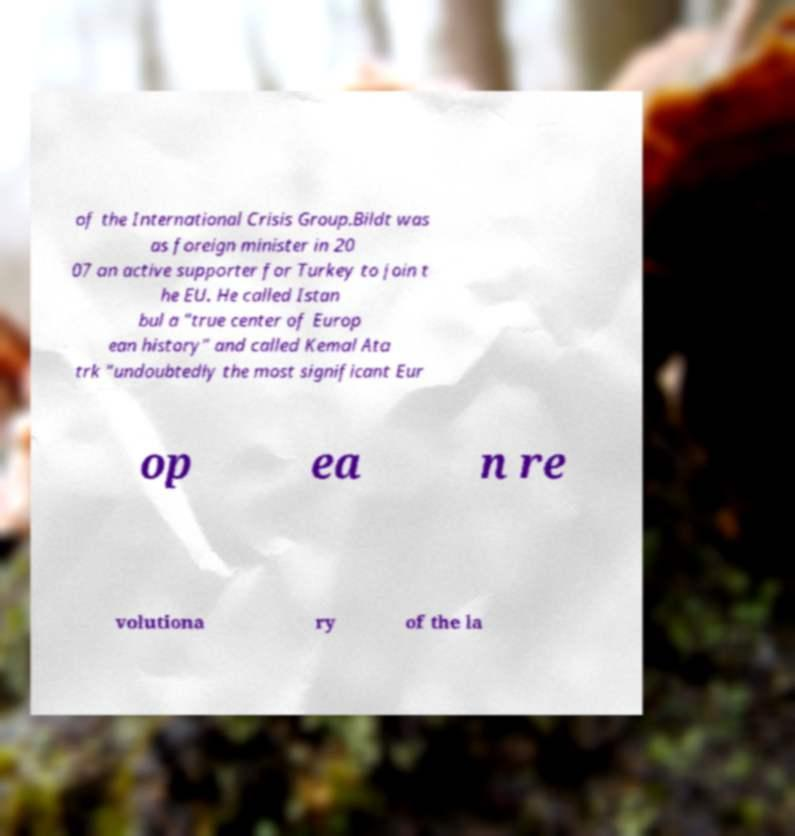Could you extract and type out the text from this image? of the International Crisis Group.Bildt was as foreign minister in 20 07 an active supporter for Turkey to join t he EU. He called Istan bul a "true center of Europ ean history" and called Kemal Ata trk "undoubtedly the most significant Eur op ea n re volutiona ry of the la 